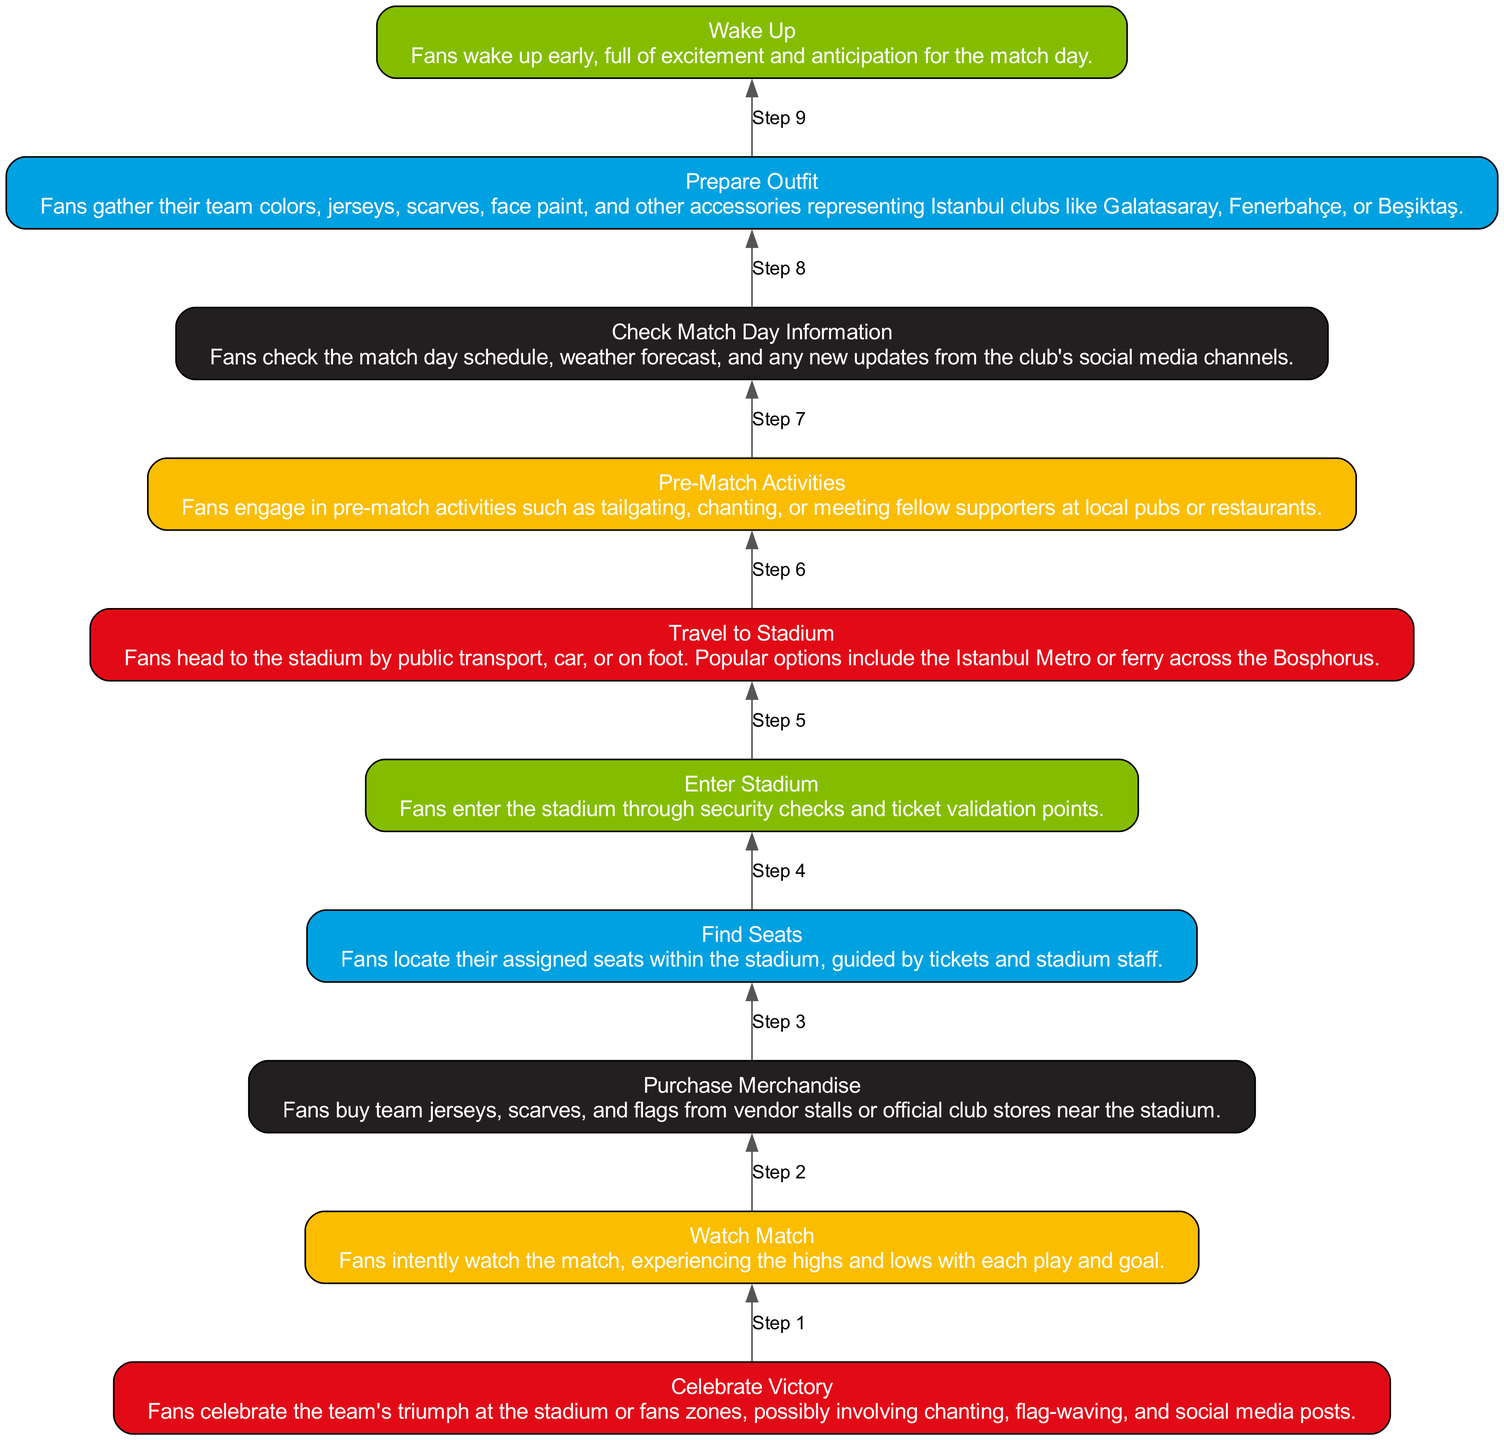What is the first step in the diagram? The diagram flows from bottom to up, starting with "Wake Up" as the first action a fan takes.
Answer: Wake Up How many total nodes are present in the diagram? By counting each distinct step represented in the diagram, we find there are ten nodes in total.
Answer: 10 What step follows "Check Match Day Information"? The diagram indicates that "Prepare Outfit" is the next action that fans take after checking match day information.
Answer: Prepare Outfit What is the last action described in the diagram? The flow concludes with "Celebrate Victory," marking the final event in the fan's match day experience.
Answer: Celebrate Victory What actions occur between "Enter Stadium" and "Watch Match"? After "Enter Stadium," fans first "Find Seats" before proceeding to "Watch Match," creating a sequence of two actions in between.
Answer: Find Seats Which step is the midpoint of the flowchart? Examining the positions of the nodes, "Join Pre-Match Activities" stands as the midpoint in the sequence, being the sixth step.
Answer: Join Pre-Match Activities How many steps involve engaging with other fans? There are three distinct steps where fans engage with others: "Travel to Stadium," "Join Pre-Match Activities," and "Watch Match."
Answer: 3 Between which two actions do fans purchase merchandise? The action of "Purchase Merchandise" falls between "Travel to Stadium" and "Find Seats," highlighting its placement in the experience flow.
Answer: Travel to Stadium and Find Seats What is the purpose of the "Check Match Day Information" step? This step serves to inform fans about essential details before the match, contributing to their readiness for the match day experience.
Answer: To inform fans 